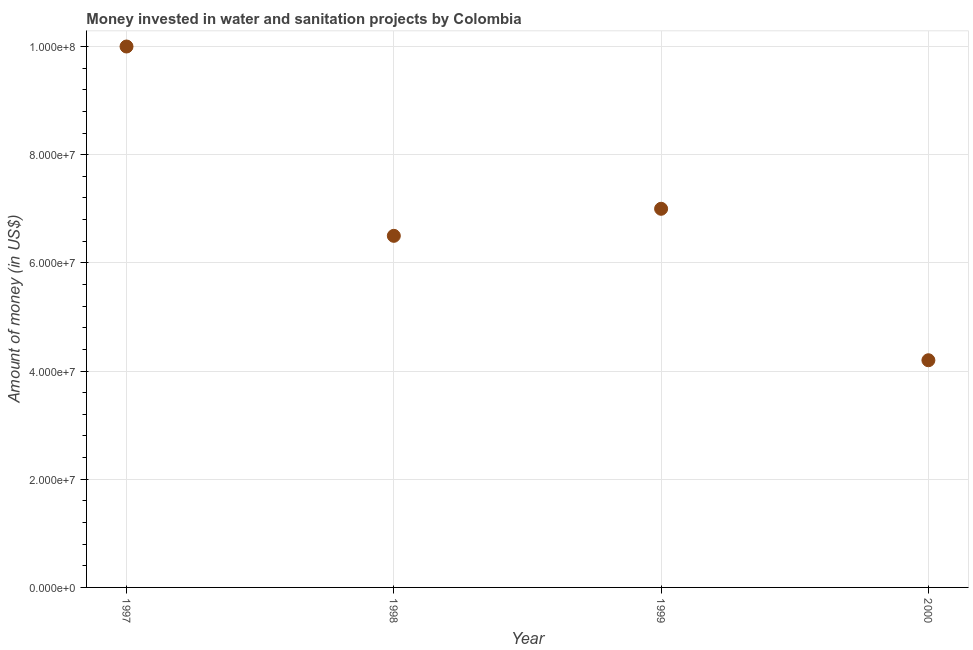What is the investment in 1999?
Offer a very short reply. 7.00e+07. Across all years, what is the maximum investment?
Offer a terse response. 1.00e+08. Across all years, what is the minimum investment?
Ensure brevity in your answer.  4.20e+07. In which year was the investment minimum?
Your response must be concise. 2000. What is the sum of the investment?
Offer a very short reply. 2.77e+08. What is the difference between the investment in 1997 and 2000?
Your answer should be compact. 5.80e+07. What is the average investment per year?
Provide a succinct answer. 6.92e+07. What is the median investment?
Give a very brief answer. 6.75e+07. What is the ratio of the investment in 1998 to that in 1999?
Give a very brief answer. 0.93. Is the difference between the investment in 1999 and 2000 greater than the difference between any two years?
Ensure brevity in your answer.  No. What is the difference between the highest and the second highest investment?
Ensure brevity in your answer.  3.00e+07. What is the difference between the highest and the lowest investment?
Offer a very short reply. 5.80e+07. In how many years, is the investment greater than the average investment taken over all years?
Offer a very short reply. 2. What is the difference between two consecutive major ticks on the Y-axis?
Make the answer very short. 2.00e+07. What is the title of the graph?
Offer a very short reply. Money invested in water and sanitation projects by Colombia. What is the label or title of the X-axis?
Make the answer very short. Year. What is the label or title of the Y-axis?
Provide a succinct answer. Amount of money (in US$). What is the Amount of money (in US$) in 1997?
Keep it short and to the point. 1.00e+08. What is the Amount of money (in US$) in 1998?
Ensure brevity in your answer.  6.50e+07. What is the Amount of money (in US$) in 1999?
Keep it short and to the point. 7.00e+07. What is the Amount of money (in US$) in 2000?
Your answer should be compact. 4.20e+07. What is the difference between the Amount of money (in US$) in 1997 and 1998?
Give a very brief answer. 3.50e+07. What is the difference between the Amount of money (in US$) in 1997 and 1999?
Your answer should be compact. 3.00e+07. What is the difference between the Amount of money (in US$) in 1997 and 2000?
Offer a terse response. 5.80e+07. What is the difference between the Amount of money (in US$) in 1998 and 1999?
Provide a short and direct response. -5.00e+06. What is the difference between the Amount of money (in US$) in 1998 and 2000?
Keep it short and to the point. 2.30e+07. What is the difference between the Amount of money (in US$) in 1999 and 2000?
Give a very brief answer. 2.80e+07. What is the ratio of the Amount of money (in US$) in 1997 to that in 1998?
Your answer should be very brief. 1.54. What is the ratio of the Amount of money (in US$) in 1997 to that in 1999?
Ensure brevity in your answer.  1.43. What is the ratio of the Amount of money (in US$) in 1997 to that in 2000?
Make the answer very short. 2.38. What is the ratio of the Amount of money (in US$) in 1998 to that in 1999?
Your answer should be very brief. 0.93. What is the ratio of the Amount of money (in US$) in 1998 to that in 2000?
Make the answer very short. 1.55. What is the ratio of the Amount of money (in US$) in 1999 to that in 2000?
Give a very brief answer. 1.67. 